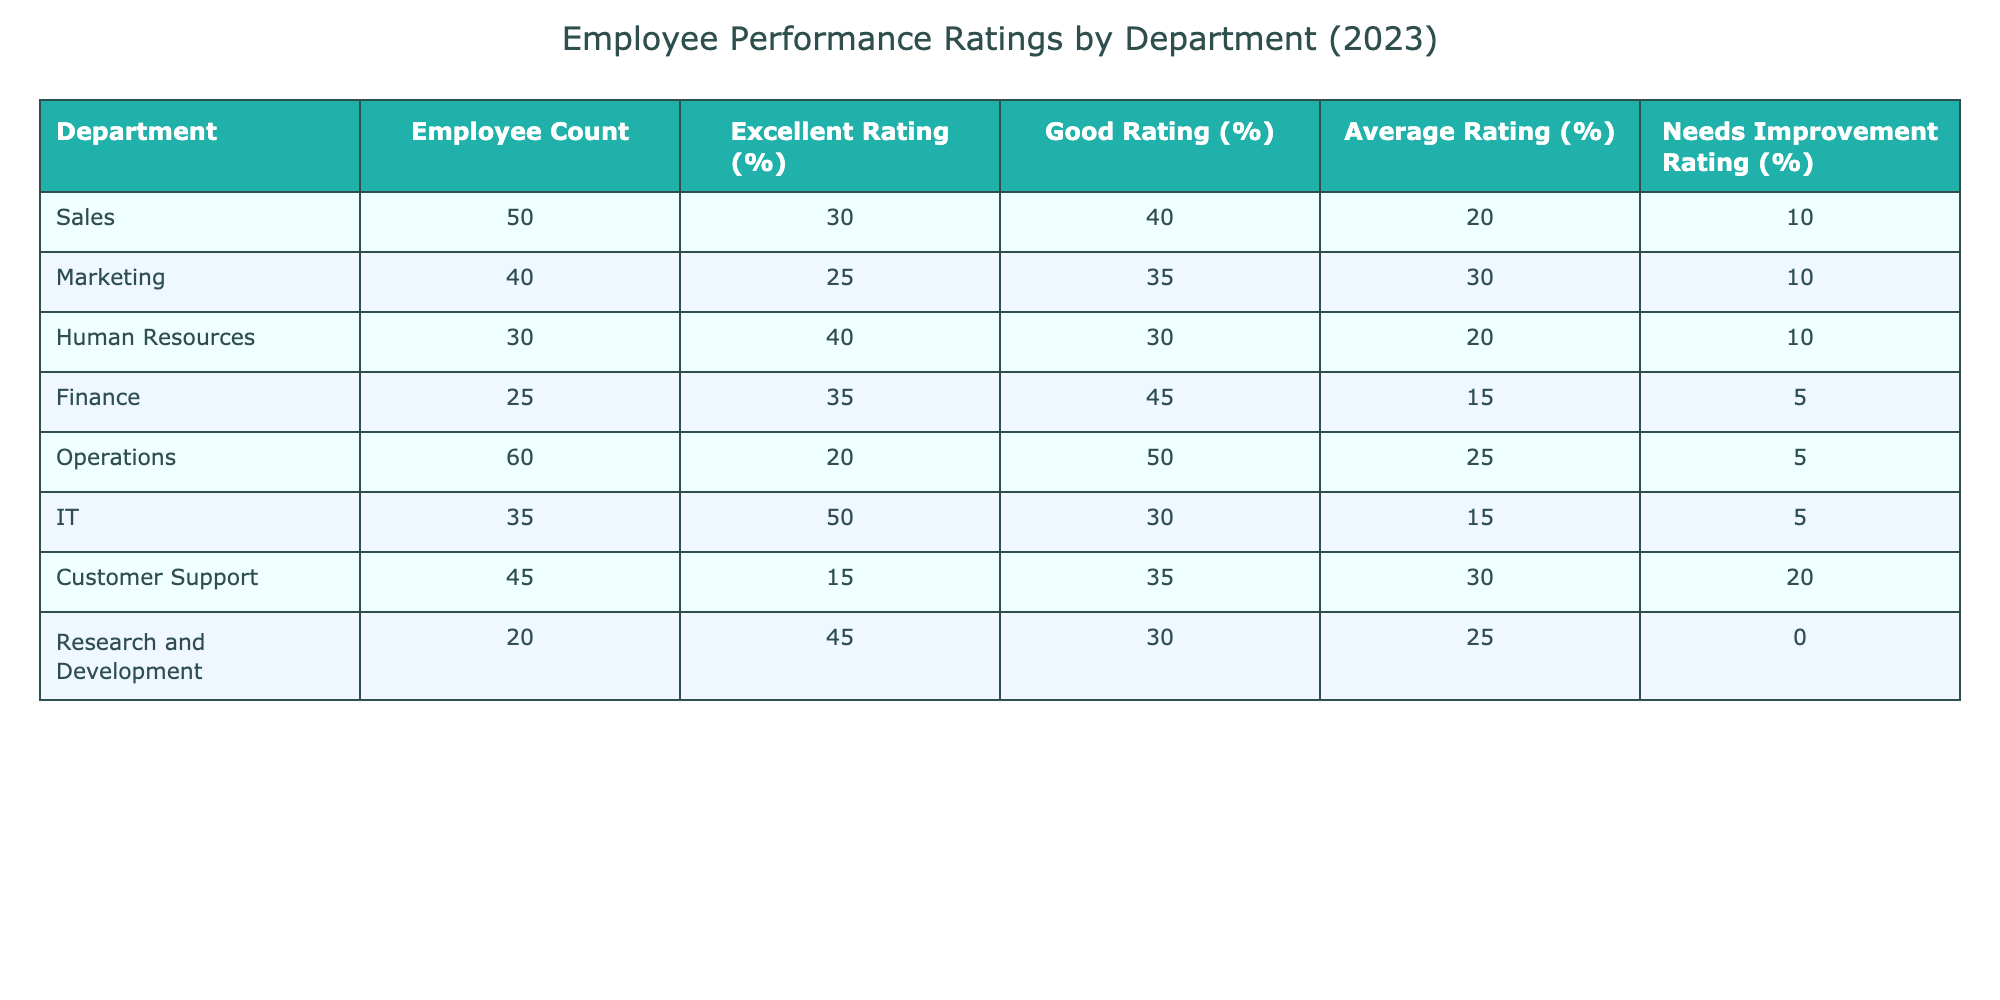What department has the highest percentage of employees rated 'Excellent'? Referring to the table, the department with the highest 'Excellent Rating (%)' is IT with 50%.
Answer: IT How many employees in the Finance department received a rating of 'Needs Improvement'? The Finance department has 25 employees and 5% of them received a 'Needs Improvement' rating. Therefore, 5% of 25 is calculated as (0.05 * 25) = 1.25, which we can round down to 1 employee.
Answer: 1 Which department has the lowest percentage of 'Good Rating'? By inspecting the table, the department with the lowest 'Good Rating (%)' is Customer Support at 35%.
Answer: Customer Support What is the average percentage of 'Average Rating (%)' across all departments? Calculate the average of the 'Average Rating (%)' values: (20 + 30 + 20 + 15 + 25 + 15 + 30 + 25) = 175. The total number of departments is 8. Thus, average = 175/8 = 21.875, which can be rounded to 22%.
Answer: 22% Is there a department with 0% 'Needs Improvement' ratings? Looking at the table, the Research and Development department has 0% 'Needs Improvement' ratings.
Answer: Yes Which department has the highest combined percentage of 'Excellent' and 'Good' ratings? For each department, sum the 'Excellent Rating (%)' and 'Good Rating (%)'. The highest combined total is found in IT, which is 50% + 30% = 80%.
Answer: IT What is the difference in the percentage of 'Excellent Rating' between Sales and Marketing? Sales has an 'Excellent Rating (%)' of 30%, while Marketing has 25%. The difference is calculated as 30% - 25% = 5%.
Answer: 5% Does the Operations department have more employees rated 'Excellent' than the Human Resources department? The Operations department has 60 employees with 20% rated 'Excellent', while Human Resources has 30 employees with 40% rated 'Excellent', calculated as (60 * 0.20) = 12 and (30 * 0.40) = 12. Thus, they are equal.
Answer: No 